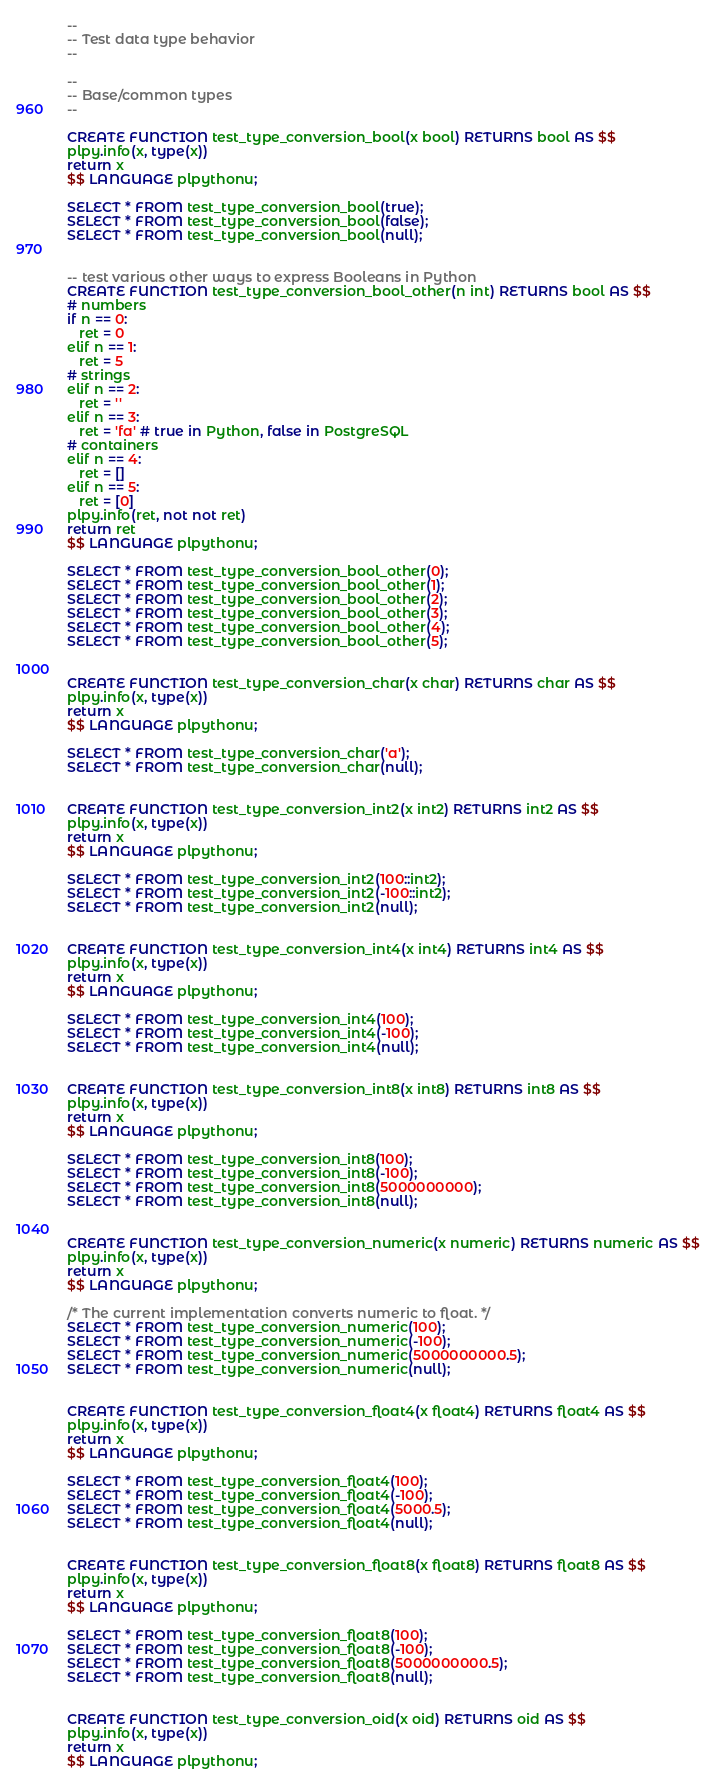Convert code to text. <code><loc_0><loc_0><loc_500><loc_500><_SQL_>--
-- Test data type behavior
--

--
-- Base/common types
--

CREATE FUNCTION test_type_conversion_bool(x bool) RETURNS bool AS $$
plpy.info(x, type(x))
return x
$$ LANGUAGE plpythonu;

SELECT * FROM test_type_conversion_bool(true);
SELECT * FROM test_type_conversion_bool(false);
SELECT * FROM test_type_conversion_bool(null);


-- test various other ways to express Booleans in Python
CREATE FUNCTION test_type_conversion_bool_other(n int) RETURNS bool AS $$
# numbers
if n == 0:
   ret = 0
elif n == 1:
   ret = 5
# strings
elif n == 2:
   ret = ''
elif n == 3:
   ret = 'fa' # true in Python, false in PostgreSQL
# containers
elif n == 4:
   ret = []
elif n == 5:
   ret = [0]
plpy.info(ret, not not ret)
return ret
$$ LANGUAGE plpythonu;

SELECT * FROM test_type_conversion_bool_other(0);
SELECT * FROM test_type_conversion_bool_other(1);
SELECT * FROM test_type_conversion_bool_other(2);
SELECT * FROM test_type_conversion_bool_other(3);
SELECT * FROM test_type_conversion_bool_other(4);
SELECT * FROM test_type_conversion_bool_other(5);


CREATE FUNCTION test_type_conversion_char(x char) RETURNS char AS $$
plpy.info(x, type(x))
return x
$$ LANGUAGE plpythonu;

SELECT * FROM test_type_conversion_char('a');
SELECT * FROM test_type_conversion_char(null);


CREATE FUNCTION test_type_conversion_int2(x int2) RETURNS int2 AS $$
plpy.info(x, type(x))
return x
$$ LANGUAGE plpythonu;

SELECT * FROM test_type_conversion_int2(100::int2);
SELECT * FROM test_type_conversion_int2(-100::int2);
SELECT * FROM test_type_conversion_int2(null);


CREATE FUNCTION test_type_conversion_int4(x int4) RETURNS int4 AS $$
plpy.info(x, type(x))
return x
$$ LANGUAGE plpythonu;

SELECT * FROM test_type_conversion_int4(100);
SELECT * FROM test_type_conversion_int4(-100);
SELECT * FROM test_type_conversion_int4(null);


CREATE FUNCTION test_type_conversion_int8(x int8) RETURNS int8 AS $$
plpy.info(x, type(x))
return x
$$ LANGUAGE plpythonu;

SELECT * FROM test_type_conversion_int8(100);
SELECT * FROM test_type_conversion_int8(-100);
SELECT * FROM test_type_conversion_int8(5000000000);
SELECT * FROM test_type_conversion_int8(null);


CREATE FUNCTION test_type_conversion_numeric(x numeric) RETURNS numeric AS $$
plpy.info(x, type(x))
return x
$$ LANGUAGE plpythonu;

/* The current implementation converts numeric to float. */
SELECT * FROM test_type_conversion_numeric(100);
SELECT * FROM test_type_conversion_numeric(-100);
SELECT * FROM test_type_conversion_numeric(5000000000.5);
SELECT * FROM test_type_conversion_numeric(null);


CREATE FUNCTION test_type_conversion_float4(x float4) RETURNS float4 AS $$
plpy.info(x, type(x))
return x
$$ LANGUAGE plpythonu;

SELECT * FROM test_type_conversion_float4(100);
SELECT * FROM test_type_conversion_float4(-100);
SELECT * FROM test_type_conversion_float4(5000.5);
SELECT * FROM test_type_conversion_float4(null);


CREATE FUNCTION test_type_conversion_float8(x float8) RETURNS float8 AS $$
plpy.info(x, type(x))
return x
$$ LANGUAGE plpythonu;

SELECT * FROM test_type_conversion_float8(100);
SELECT * FROM test_type_conversion_float8(-100);
SELECT * FROM test_type_conversion_float8(5000000000.5);
SELECT * FROM test_type_conversion_float8(null);


CREATE FUNCTION test_type_conversion_oid(x oid) RETURNS oid AS $$
plpy.info(x, type(x))
return x
$$ LANGUAGE plpythonu;
</code> 